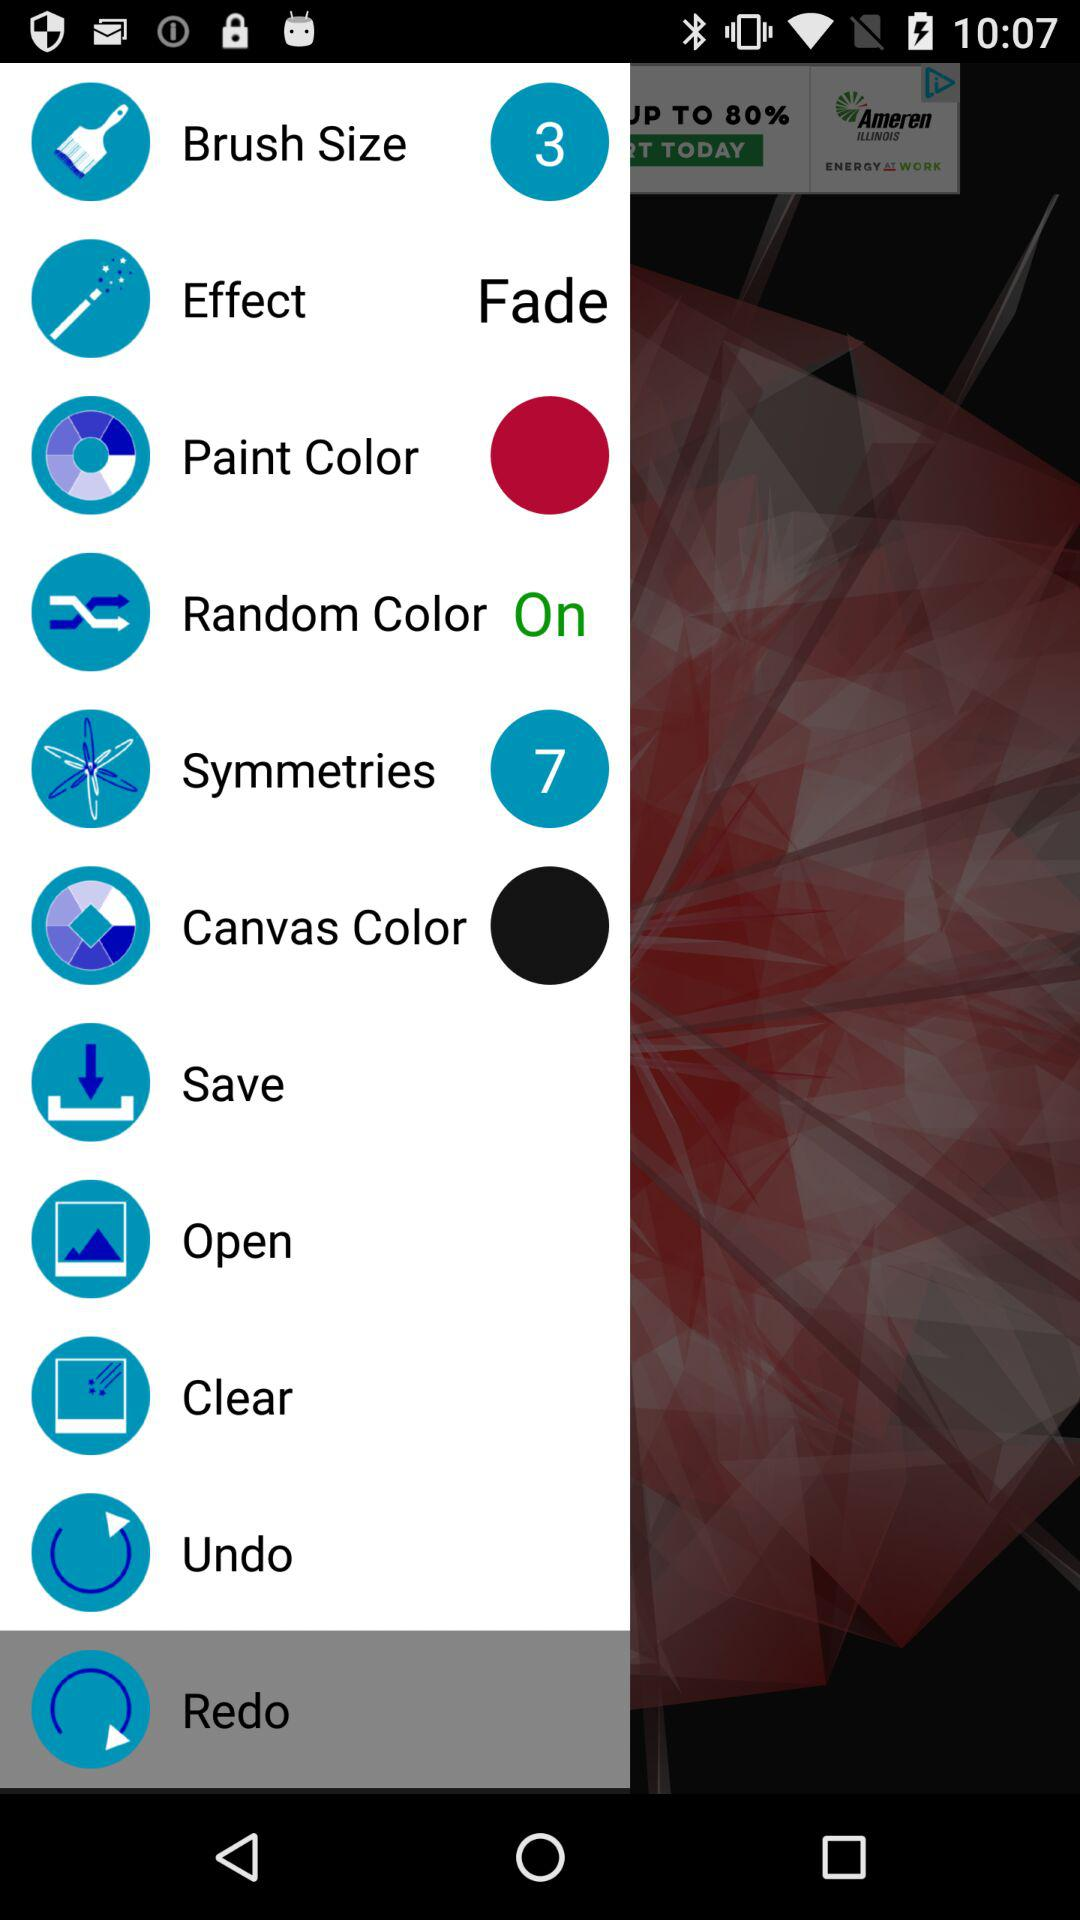How many symmetries are available? There are 7 symmetries available. 